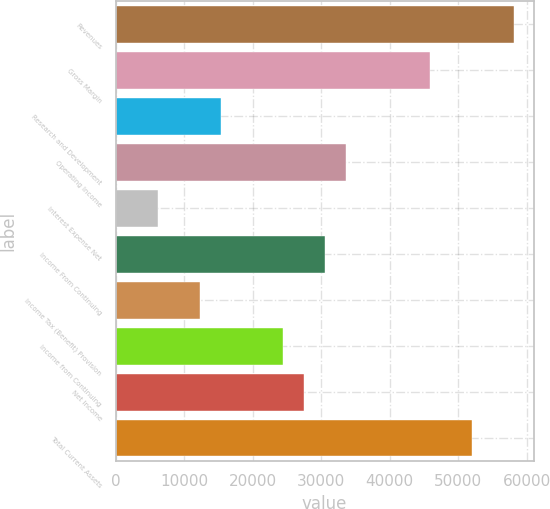<chart> <loc_0><loc_0><loc_500><loc_500><bar_chart><fcel>Revenues<fcel>Gross Margin<fcel>Research and Development<fcel>Operating Income<fcel>Interest Expense Net<fcel>Income From Continuing<fcel>Income Tax (Benefit) Provision<fcel>Income from Continuing<fcel>Net Income<fcel>Total Current Assets<nl><fcel>58116.4<fcel>45886.9<fcel>15313.2<fcel>33657.4<fcel>6141.07<fcel>30600<fcel>12255.8<fcel>24485.3<fcel>27542.7<fcel>52001.6<nl></chart> 